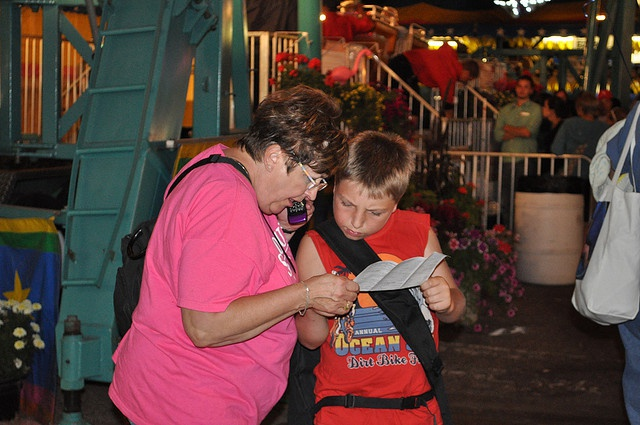Describe the objects in this image and their specific colors. I can see people in black, salmon, and brown tones, people in black and brown tones, backpack in black, maroon, brown, and darkgray tones, handbag in black, darkgray, gray, and navy tones, and people in black and maroon tones in this image. 